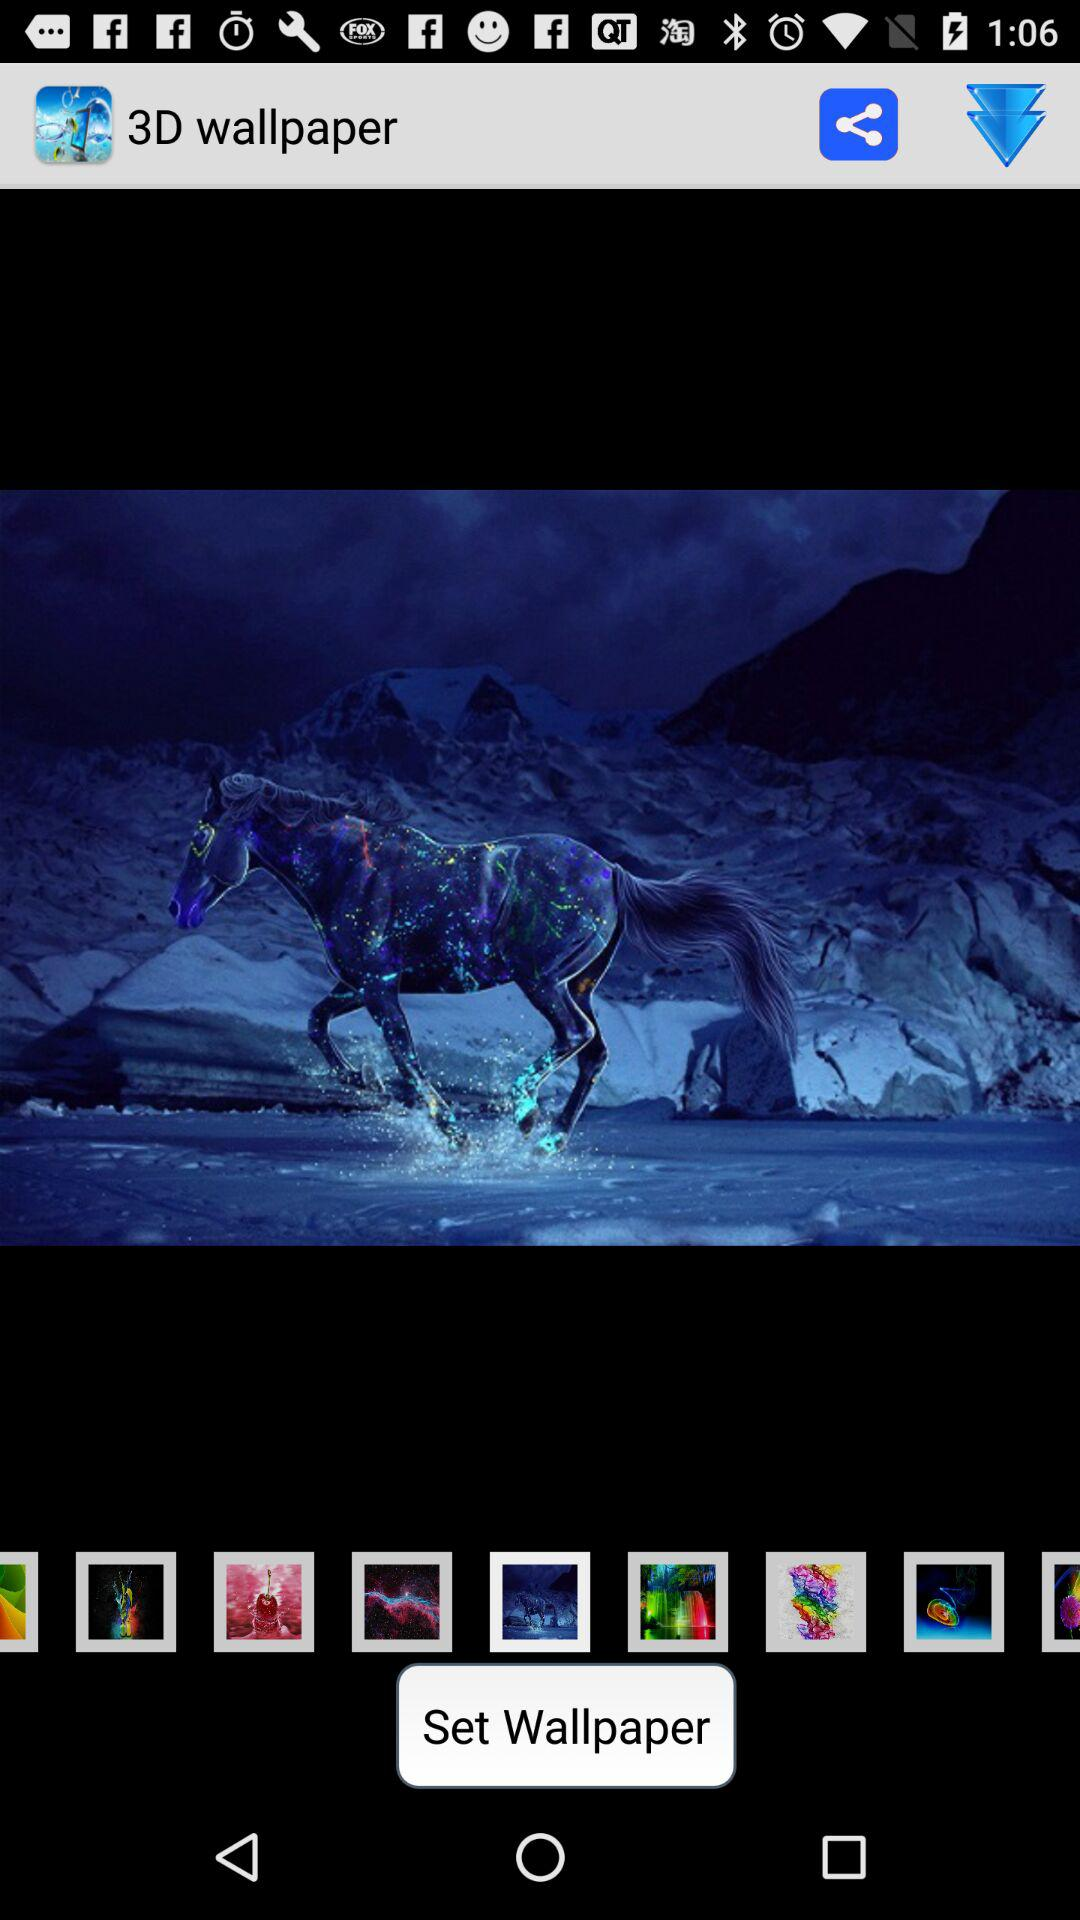What is the type of wallpaper in the application?
When the provided information is insufficient, respond with <no answer>. <no answer> 